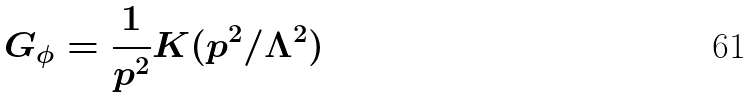<formula> <loc_0><loc_0><loc_500><loc_500>G _ { \phi } = \frac { 1 } { p ^ { 2 } } K ( p ^ { 2 } / \Lambda ^ { 2 } )</formula> 